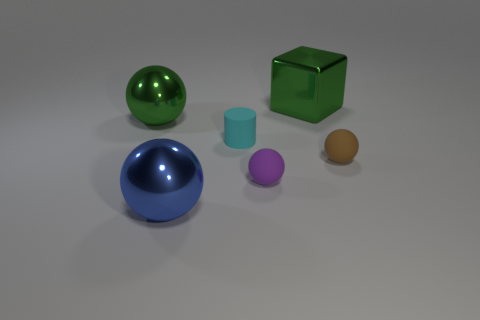Subtract 1 spheres. How many spheres are left? 3 Add 1 cyan objects. How many objects exist? 7 Subtract all spheres. How many objects are left? 2 Add 3 blue spheres. How many blue spheres are left? 4 Add 5 tiny rubber objects. How many tiny rubber objects exist? 8 Subtract 1 cyan cylinders. How many objects are left? 5 Subtract all large yellow rubber cubes. Subtract all big green spheres. How many objects are left? 5 